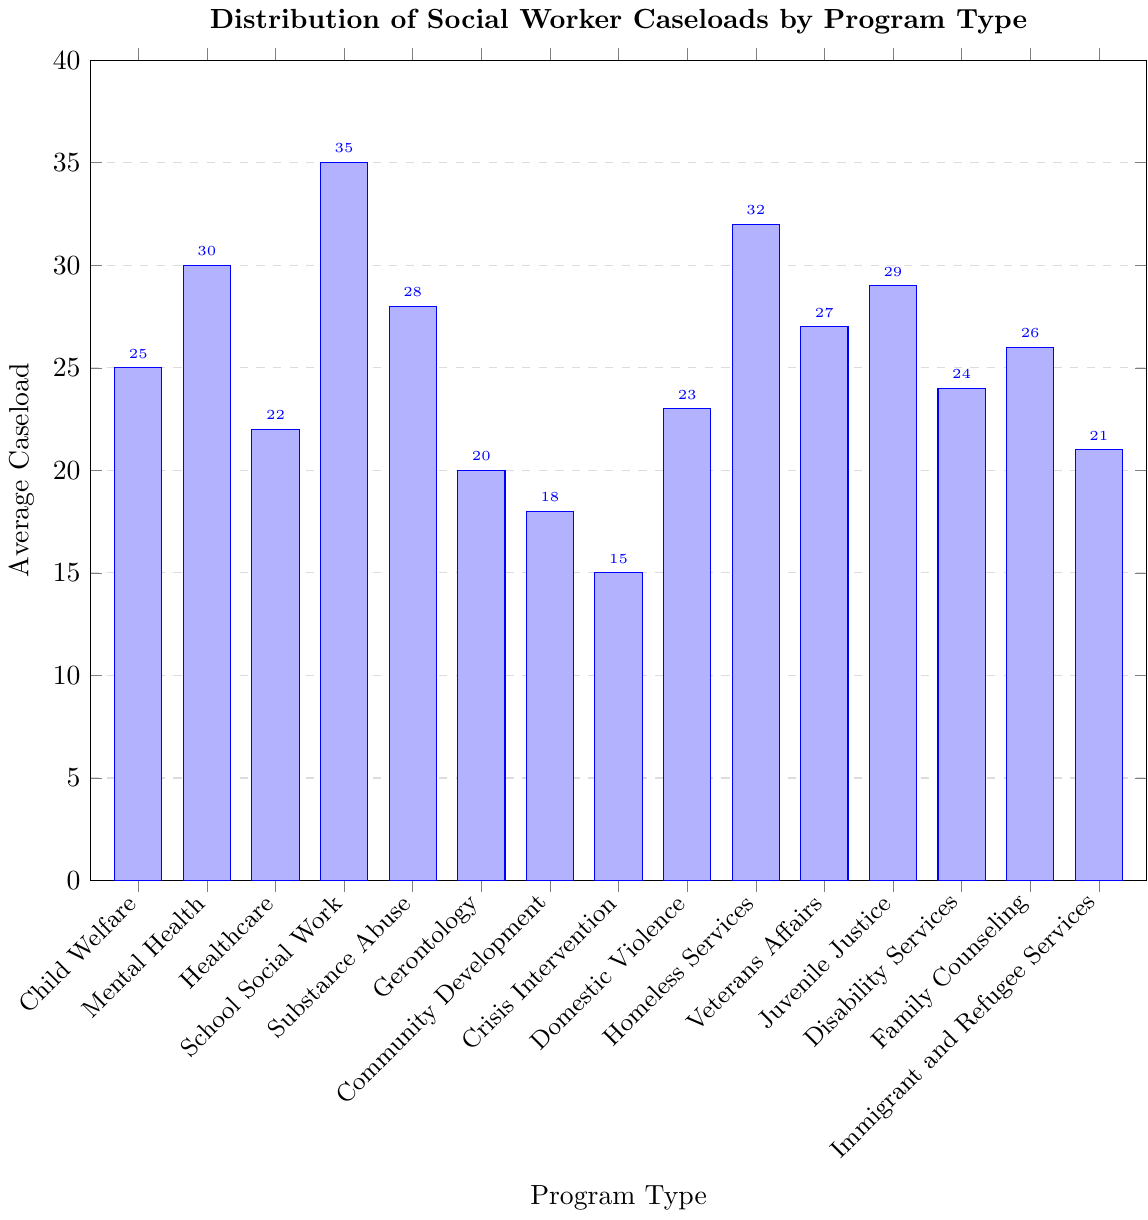Which program type has the highest average caseload? The bar for School Social Work is the tallest, indicating the highest average caseload.
Answer: School Social Work Which program type has the lowest average caseload? The bar for Crisis Intervention is the shortest, indicating the lowest average caseload.
Answer: Crisis Intervention How many programs have an average caseload greater than 30? Visually, Mental Health, School Social Work, and Homeless Services have bars higher than 30. So, there are 3 programs.
Answer: 3 What is the difference in average caseload between School Social Work and Crisis Intervention? School Social Work has an average caseload of 35, and Crisis Intervention has 15. The difference is 35 - 15 = 20.
Answer: 20 Which program types have an average caseload between 20 and 25? Looking at the bars within the 20-25 range, we see Child Welfare, Healthcare, Gerontology, Domestic Violence, Disability Services, and Immigrant and Refugee Services.
Answer: Child Welfare, Healthcare, Gerontology, Domestic Violence, Disability Services, Immigrant and Refugee Services Is the average caseload for Mental Health greater than for Substance Abuse? Comparing the heights, Mental Health has a caseload of 30, and Substance Abuse has 28, so Mental Health is greater.
Answer: Yes What is the total average caseload for Veterans Affairs and Juvenile Justice combined? Veterans Affairs has an average caseload of 27, and Juvenile Justice has 29. Combined, the total is 27 + 29 = 56.
Answer: 56 Which program type has an average caseload closest to 25? By examining the bars, Child Welfare has an average caseload of exactly 25.
Answer: Child Welfare How many program types have an average caseload less than 20? Programs with bars lower than 20 are Community Development and Crisis Intervention, making a total of 2 programs.
Answer: 2 